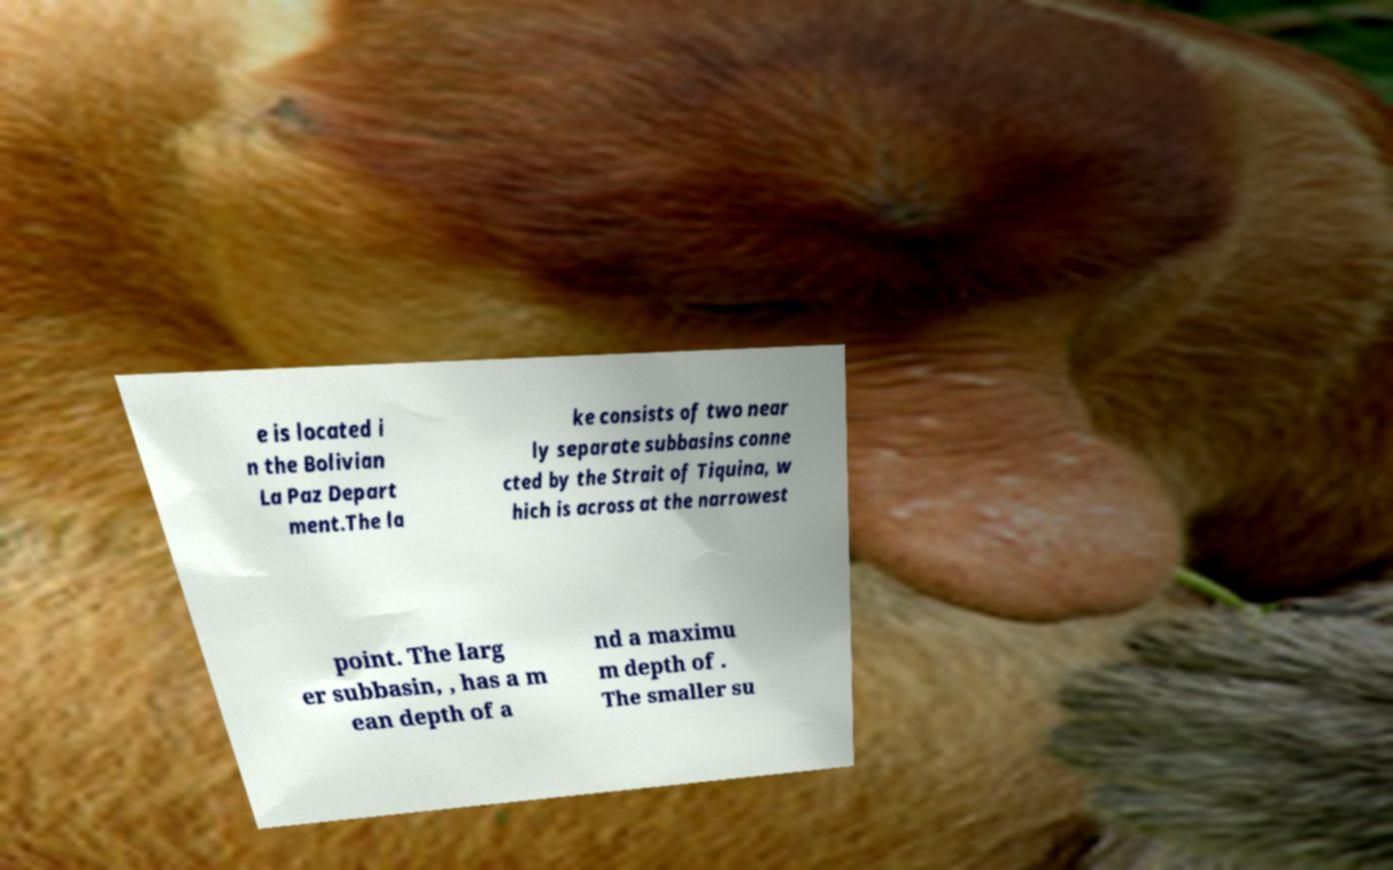There's text embedded in this image that I need extracted. Can you transcribe it verbatim? e is located i n the Bolivian La Paz Depart ment.The la ke consists of two near ly separate subbasins conne cted by the Strait of Tiquina, w hich is across at the narrowest point. The larg er subbasin, , has a m ean depth of a nd a maximu m depth of . The smaller su 